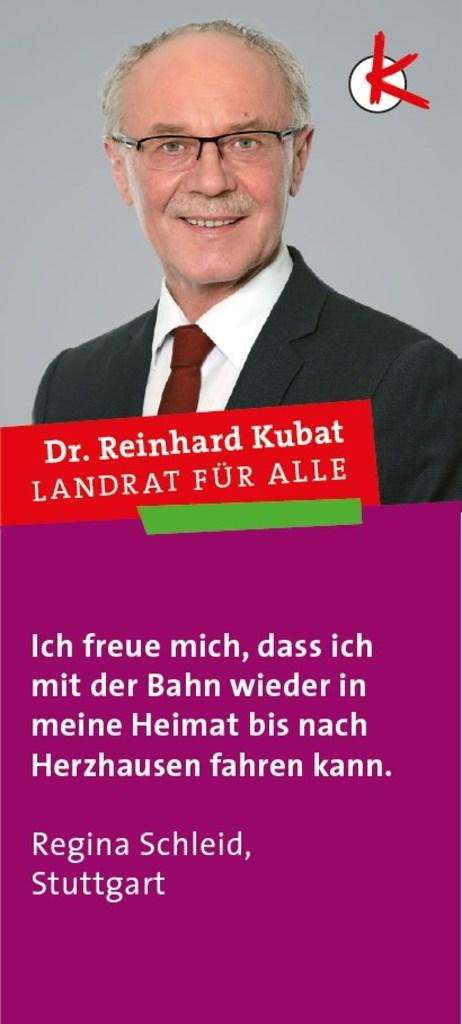What is featured in the image? There is a poster in the image. What is the person on the poster doing? The person on the poster is smiling. What else can be found on the poster besides the image of the person? There is text present on the poster. How many balloons are attached to the nation depicted on the poster? There is no nation or balloons present on the poster; it features a person smiling with text. 